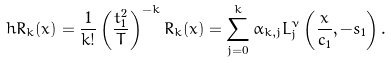<formula> <loc_0><loc_0><loc_500><loc_500>\ h R _ { k } ( x ) = \frac { 1 } { k ! } \left ( \frac { t _ { 1 } ^ { 2 } } { T } \right ) ^ { - k } R _ { k } ( x ) = \sum _ { j = 0 } ^ { k } \alpha _ { k , j } L _ { j } ^ { \nu } \left ( \frac { x } { c _ { 1 } } , - s _ { 1 } \right ) .</formula> 